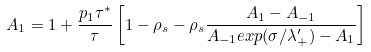Convert formula to latex. <formula><loc_0><loc_0><loc_500><loc_500>A _ { 1 } = 1 + \frac { p _ { 1 } \tau ^ { * } } { \tau } \left [ 1 - \rho _ { s } - \rho _ { s } \frac { A _ { 1 } - A _ { - 1 } } { A _ { - 1 } e x p ( \sigma / \lambda ^ { \prime } _ { + } ) - A _ { 1 } } \right ]</formula> 